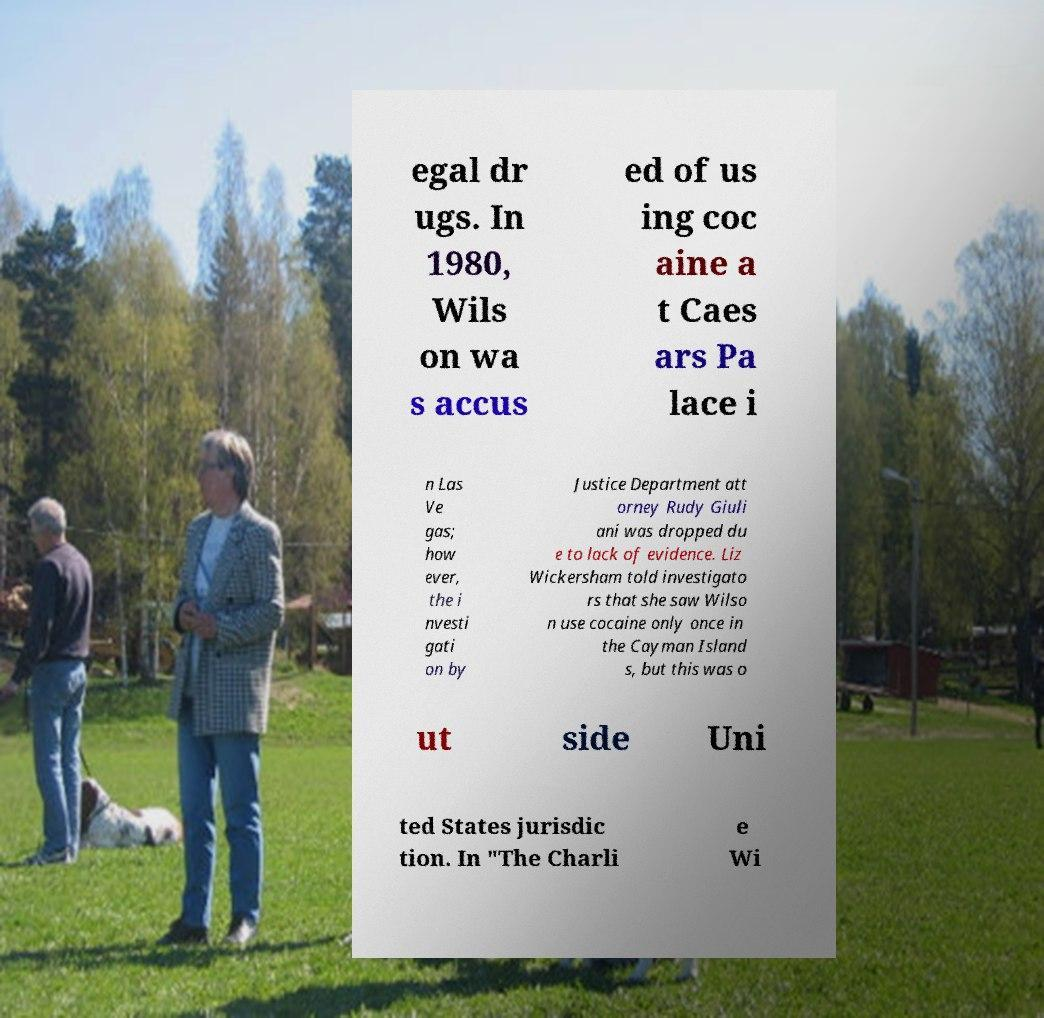Could you extract and type out the text from this image? egal dr ugs. In 1980, Wils on wa s accus ed of us ing coc aine a t Caes ars Pa lace i n Las Ve gas; how ever, the i nvesti gati on by Justice Department att orney Rudy Giuli ani was dropped du e to lack of evidence. Liz Wickersham told investigato rs that she saw Wilso n use cocaine only once in the Cayman Island s, but this was o ut side Uni ted States jurisdic tion. In "The Charli e Wi 